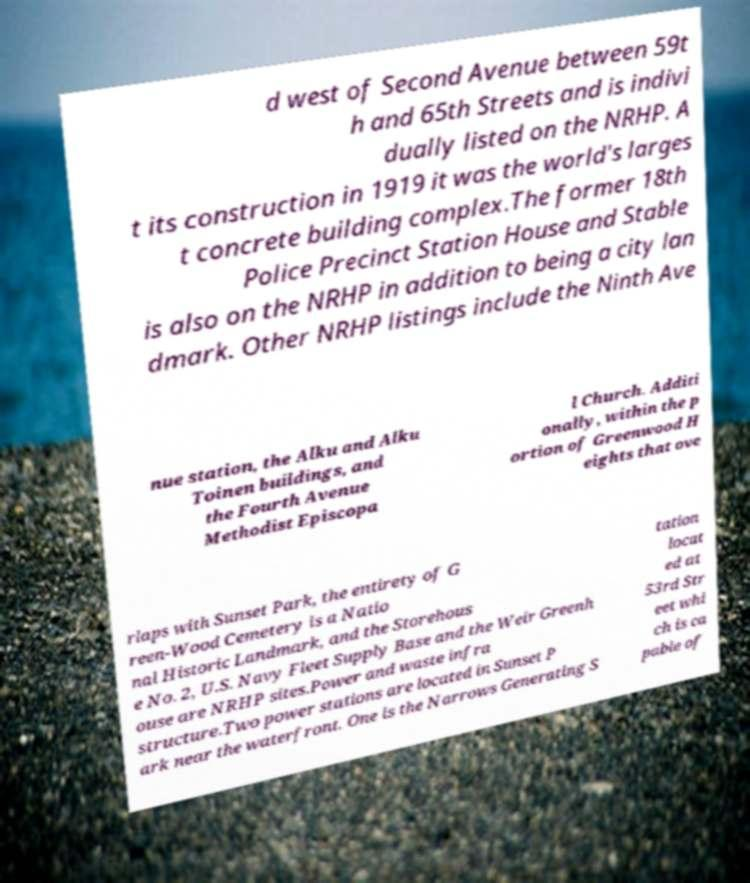There's text embedded in this image that I need extracted. Can you transcribe it verbatim? d west of Second Avenue between 59t h and 65th Streets and is indivi dually listed on the NRHP. A t its construction in 1919 it was the world's larges t concrete building complex.The former 18th Police Precinct Station House and Stable is also on the NRHP in addition to being a city lan dmark. Other NRHP listings include the Ninth Ave nue station, the Alku and Alku Toinen buildings, and the Fourth Avenue Methodist Episcopa l Church. Additi onally, within the p ortion of Greenwood H eights that ove rlaps with Sunset Park, the entirety of G reen-Wood Cemetery is a Natio nal Historic Landmark, and the Storehous e No. 2, U.S. Navy Fleet Supply Base and the Weir Greenh ouse are NRHP sites.Power and waste infra structure.Two power stations are located in Sunset P ark near the waterfront. One is the Narrows Generating S tation locat ed at 53rd Str eet whi ch is ca pable of 